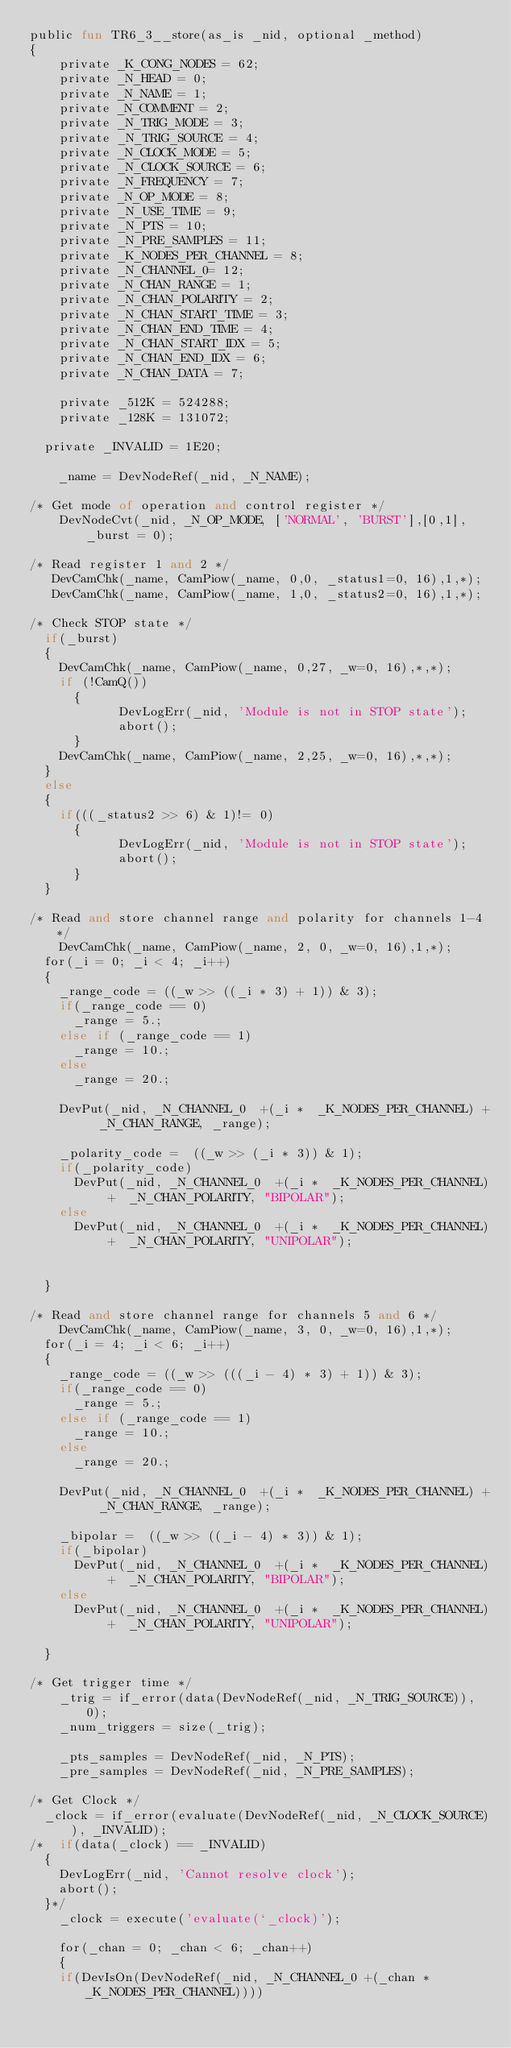<code> <loc_0><loc_0><loc_500><loc_500><_SML_>public fun TR6_3__store(as_is _nid, optional _method)
{
    private _K_CONG_NODES = 62;
    private _N_HEAD = 0;
    private _N_NAME = 1;
    private _N_COMMENT = 2;
    private _N_TRIG_MODE = 3;
    private _N_TRIG_SOURCE = 4;
    private _N_CLOCK_MODE = 5;
    private _N_CLOCK_SOURCE = 6;
    private _N_FREQUENCY = 7;
    private _N_OP_MODE = 8;
    private _N_USE_TIME = 9;
    private _N_PTS = 10;
    private _N_PRE_SAMPLES = 11;
    private _K_NODES_PER_CHANNEL = 8;
    private _N_CHANNEL_0= 12;
    private _N_CHAN_RANGE = 1;
    private _N_CHAN_POLARITY = 2;
    private _N_CHAN_START_TIME = 3;
    private _N_CHAN_END_TIME = 4;
    private _N_CHAN_START_IDX = 5;
    private _N_CHAN_END_IDX = 6;
    private _N_CHAN_DATA = 7;
  
    private _512K = 524288;
    private _128K = 131072;

	private _INVALID = 1E20;

    _name = DevNodeRef(_nid, _N_NAME);

/* Get mode of operation and control register */
    DevNodeCvt(_nid, _N_OP_MODE, ['NORMAL', 'BURST'],[0,1], _burst = 0);

/* Read register 1 and 2 */
   DevCamChk(_name, CamPiow(_name, 0,0, _status1=0, 16),1,*);
   DevCamChk(_name, CamPiow(_name, 1,0, _status2=0, 16),1,*);

/* Check STOP state */
	if(_burst)
	{
		DevCamChk(_name, CamPiow(_name, 0,27, _w=0, 16),*,*);
		if (!CamQ())
    	{
            DevLogErr(_nid, 'Module is not in STOP state');
            abort();
    	}
		DevCamChk(_name, CamPiow(_name, 2,25, _w=0, 16),*,*);
	}
	else
	{
		if(((_status2 >> 6) & 1)!= 0)
    	{
            DevLogErr(_nid, 'Module is not in STOP state');
            abort();
    	}
	}

/* Read and store channel range and polarity for channels 1-4 */
    DevCamChk(_name, CamPiow(_name, 2, 0, _w=0, 16),1,*); 
	for(_i = 0; _i < 4; _i++)
	{
		_range_code = ((_w >> ((_i * 3) + 1)) & 3);
		if(_range_code == 0)
			_range = 5.;
		else if (_range_code == 1)
			_range = 10.;
		else
			_range = 20.;

		DevPut(_nid, _N_CHANNEL_0  +(_i *  _K_NODES_PER_CHANNEL) +  _N_CHAN_RANGE, _range);

		_polarity_code =  ((_w >> (_i * 3)) & 1);
		if(_polarity_code)
			DevPut(_nid, _N_CHANNEL_0  +(_i *  _K_NODES_PER_CHANNEL) +  _N_CHAN_POLARITY, "BIPOLAR");
		else
			DevPut(_nid, _N_CHANNEL_0  +(_i *  _K_NODES_PER_CHANNEL) +  _N_CHAN_POLARITY, "UNIPOLAR");


	}

/* Read and store channel range for channels 5 and 6 */
    DevCamChk(_name, CamPiow(_name, 3, 0, _w=0, 16),1,*); 
	for(_i = 4; _i < 6; _i++)
	{
		_range_code = ((_w >> (((_i - 4) * 3) + 1)) & 3);
		if(_range_code == 0)
			_range = 5.;
		else if (_range_code == 1)
			_range = 10.;
		else
			_range = 20.;

		DevPut(_nid, _N_CHANNEL_0  +(_i *  _K_NODES_PER_CHANNEL) +  _N_CHAN_RANGE, _range);

		_bipolar =  ((_w >> ((_i - 4) * 3)) & 1);
		if(_bipolar)
			DevPut(_nid, _N_CHANNEL_0  +(_i *  _K_NODES_PER_CHANNEL) +  _N_CHAN_POLARITY, "BIPOLAR");
		else
			DevPut(_nid, _N_CHANNEL_0  +(_i *  _K_NODES_PER_CHANNEL) +  _N_CHAN_POLARITY, "UNIPOLAR");

	}

/* Get trigger time */
    _trig = if_error(data(DevNodeRef(_nid, _N_TRIG_SOURCE)), 0);
    _num_triggers = size(_trig);

    _pts_samples = DevNodeRef(_nid, _N_PTS); 
    _pre_samples = DevNodeRef(_nid, _N_PRE_SAMPLES); 

/* Get Clock */
	_clock = if_error(evaluate(DevNodeRef(_nid, _N_CLOCK_SOURCE)), _INVALID);
/*	if(data(_clock) == _INVALID)
	{
		DevLogErr(_nid, 'Cannot resolve clock');
		abort();
	}*/
    _clock = execute('evaluate(`_clock)');

    for(_chan = 0; _chan < 6; _chan++)
    {
		if(DevIsOn(DevNodeRef(_nid, _N_CHANNEL_0 +(_chan *  _K_NODES_PER_CHANNEL))))</code> 